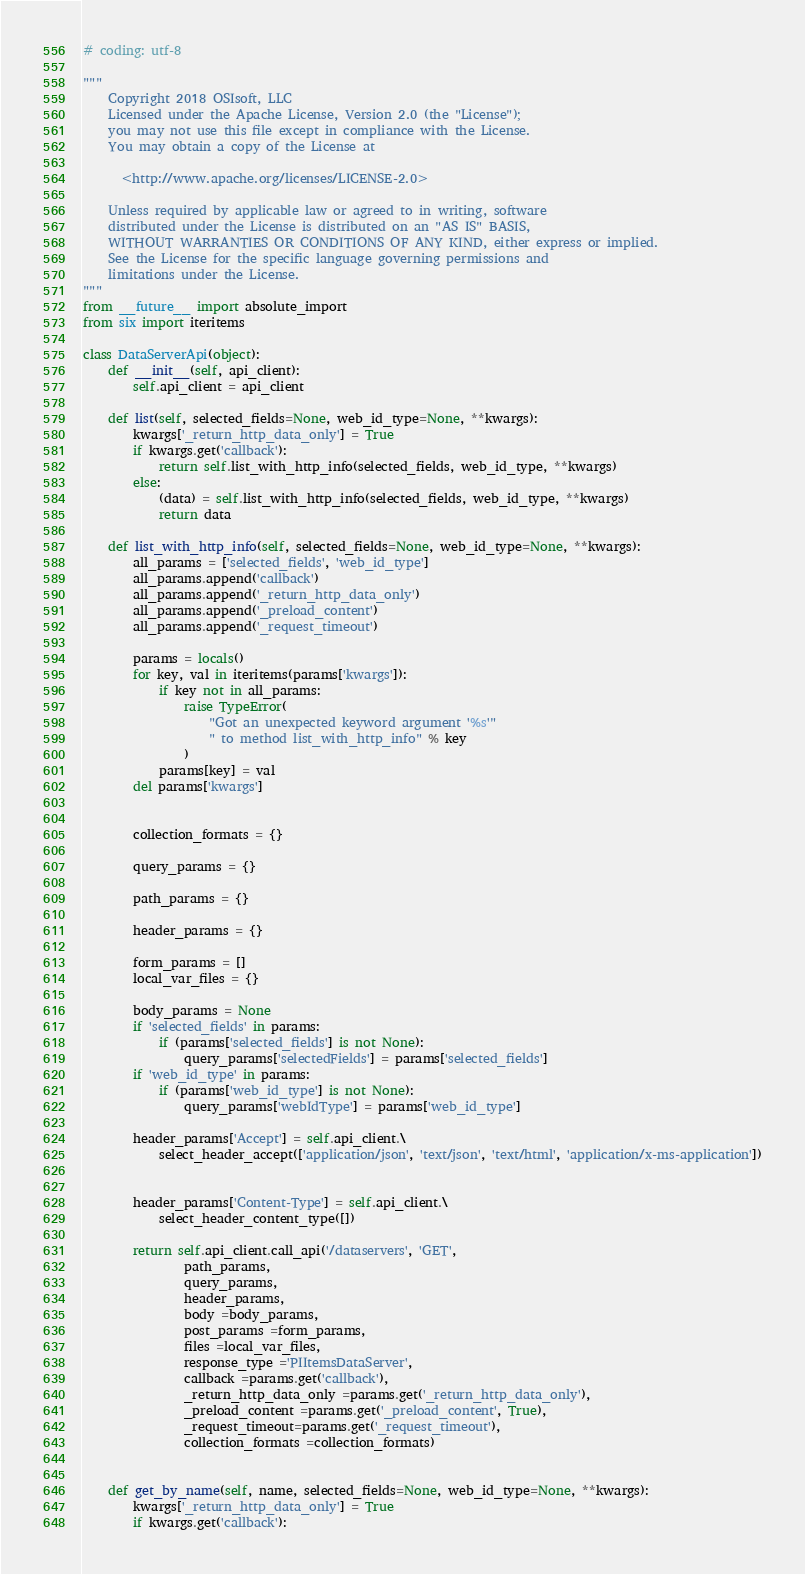Convert code to text. <code><loc_0><loc_0><loc_500><loc_500><_Python_># coding: utf-8

"""
	Copyright 2018 OSIsoft, LLC
	Licensed under the Apache License, Version 2.0 (the "License");
	you may not use this file except in compliance with the License.
	You may obtain a copy of the License at
	
	  <http://www.apache.org/licenses/LICENSE-2.0>
	
	Unless required by applicable law or agreed to in writing, software
	distributed under the License is distributed on an "AS IS" BASIS,
	WITHOUT WARRANTIES OR CONDITIONS OF ANY KIND, either express or implied.
	See the License for the specific language governing permissions and
	limitations under the License.
"""
from __future__ import absolute_import
from six import iteritems

class DataServerApi(object):
	def __init__(self, api_client):
		self.api_client = api_client

	def list(self, selected_fields=None, web_id_type=None, **kwargs):
		kwargs['_return_http_data_only'] = True
		if kwargs.get('callback'):
			return self.list_with_http_info(selected_fields, web_id_type, **kwargs)
		else:
			(data) = self.list_with_http_info(selected_fields, web_id_type, **kwargs)
			return data

	def list_with_http_info(self, selected_fields=None, web_id_type=None, **kwargs):
		all_params = ['selected_fields', 'web_id_type']
		all_params.append('callback')
		all_params.append('_return_http_data_only')
		all_params.append('_preload_content')
		all_params.append('_request_timeout')

		params = locals()
		for key, val in iteritems(params['kwargs']):
			if key not in all_params:
				raise TypeError(
					"Got an unexpected keyword argument '%s'"
					" to method list_with_http_info" % key
				)
			params[key] = val
		del params['kwargs']


		collection_formats = {}

		query_params = {}

		path_params = {}

		header_params = {}

		form_params = []
		local_var_files = {}

		body_params = None
		if 'selected_fields' in params:
			if (params['selected_fields'] is not None):
				query_params['selectedFields'] = params['selected_fields']
		if 'web_id_type' in params:
			if (params['web_id_type'] is not None):
				query_params['webIdType'] = params['web_id_type']

		header_params['Accept'] = self.api_client.\
			select_header_accept(['application/json', 'text/json', 'text/html', 'application/x-ms-application'])


		header_params['Content-Type'] = self.api_client.\
			select_header_content_type([])

		return self.api_client.call_api('/dataservers', 'GET',
				path_params,
				query_params,
				header_params,
				body =body_params,
				post_params =form_params,
				files =local_var_files,
				response_type ='PIItemsDataServer',
				callback =params.get('callback'),
				_return_http_data_only =params.get('_return_http_data_only'),
				_preload_content =params.get('_preload_content', True),
				_request_timeout=params.get('_request_timeout'),
				collection_formats =collection_formats)


	def get_by_name(self, name, selected_fields=None, web_id_type=None, **kwargs):
		kwargs['_return_http_data_only'] = True
		if kwargs.get('callback'):</code> 